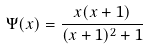Convert formula to latex. <formula><loc_0><loc_0><loc_500><loc_500>\Psi ( x ) = \frac { x ( x + 1 ) } { ( x + 1 ) ^ { 2 } + 1 }</formula> 